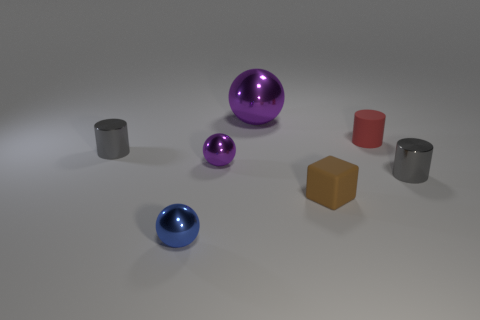Subtract all gray spheres. Subtract all cyan blocks. How many spheres are left? 3 Add 1 things. How many objects exist? 8 Subtract all spheres. How many objects are left? 4 Subtract all large purple metal things. Subtract all brown things. How many objects are left? 5 Add 2 large things. How many large things are left? 3 Add 4 small yellow metallic cylinders. How many small yellow metallic cylinders exist? 4 Subtract 0 green blocks. How many objects are left? 7 